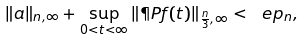<formula> <loc_0><loc_0><loc_500><loc_500>\| a \| _ { n , \infty } + \sup _ { 0 < t < \infty } \| \P P f ( t ) \| _ { \frac { n } { 3 } , \infty } < \ e p _ { n } ,</formula> 